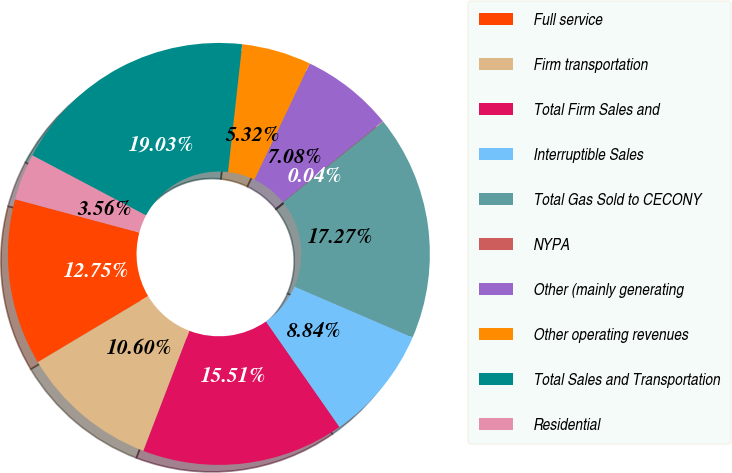Convert chart to OTSL. <chart><loc_0><loc_0><loc_500><loc_500><pie_chart><fcel>Full service<fcel>Firm transportation<fcel>Total Firm Sales and<fcel>Interruptible Sales<fcel>Total Gas Sold to CECONY<fcel>NYPA<fcel>Other (mainly generating<fcel>Other operating revenues<fcel>Total Sales and Transportation<fcel>Residential<nl><fcel>12.75%<fcel>10.6%<fcel>15.51%<fcel>8.84%<fcel>17.27%<fcel>0.04%<fcel>7.08%<fcel>5.32%<fcel>19.03%<fcel>3.56%<nl></chart> 